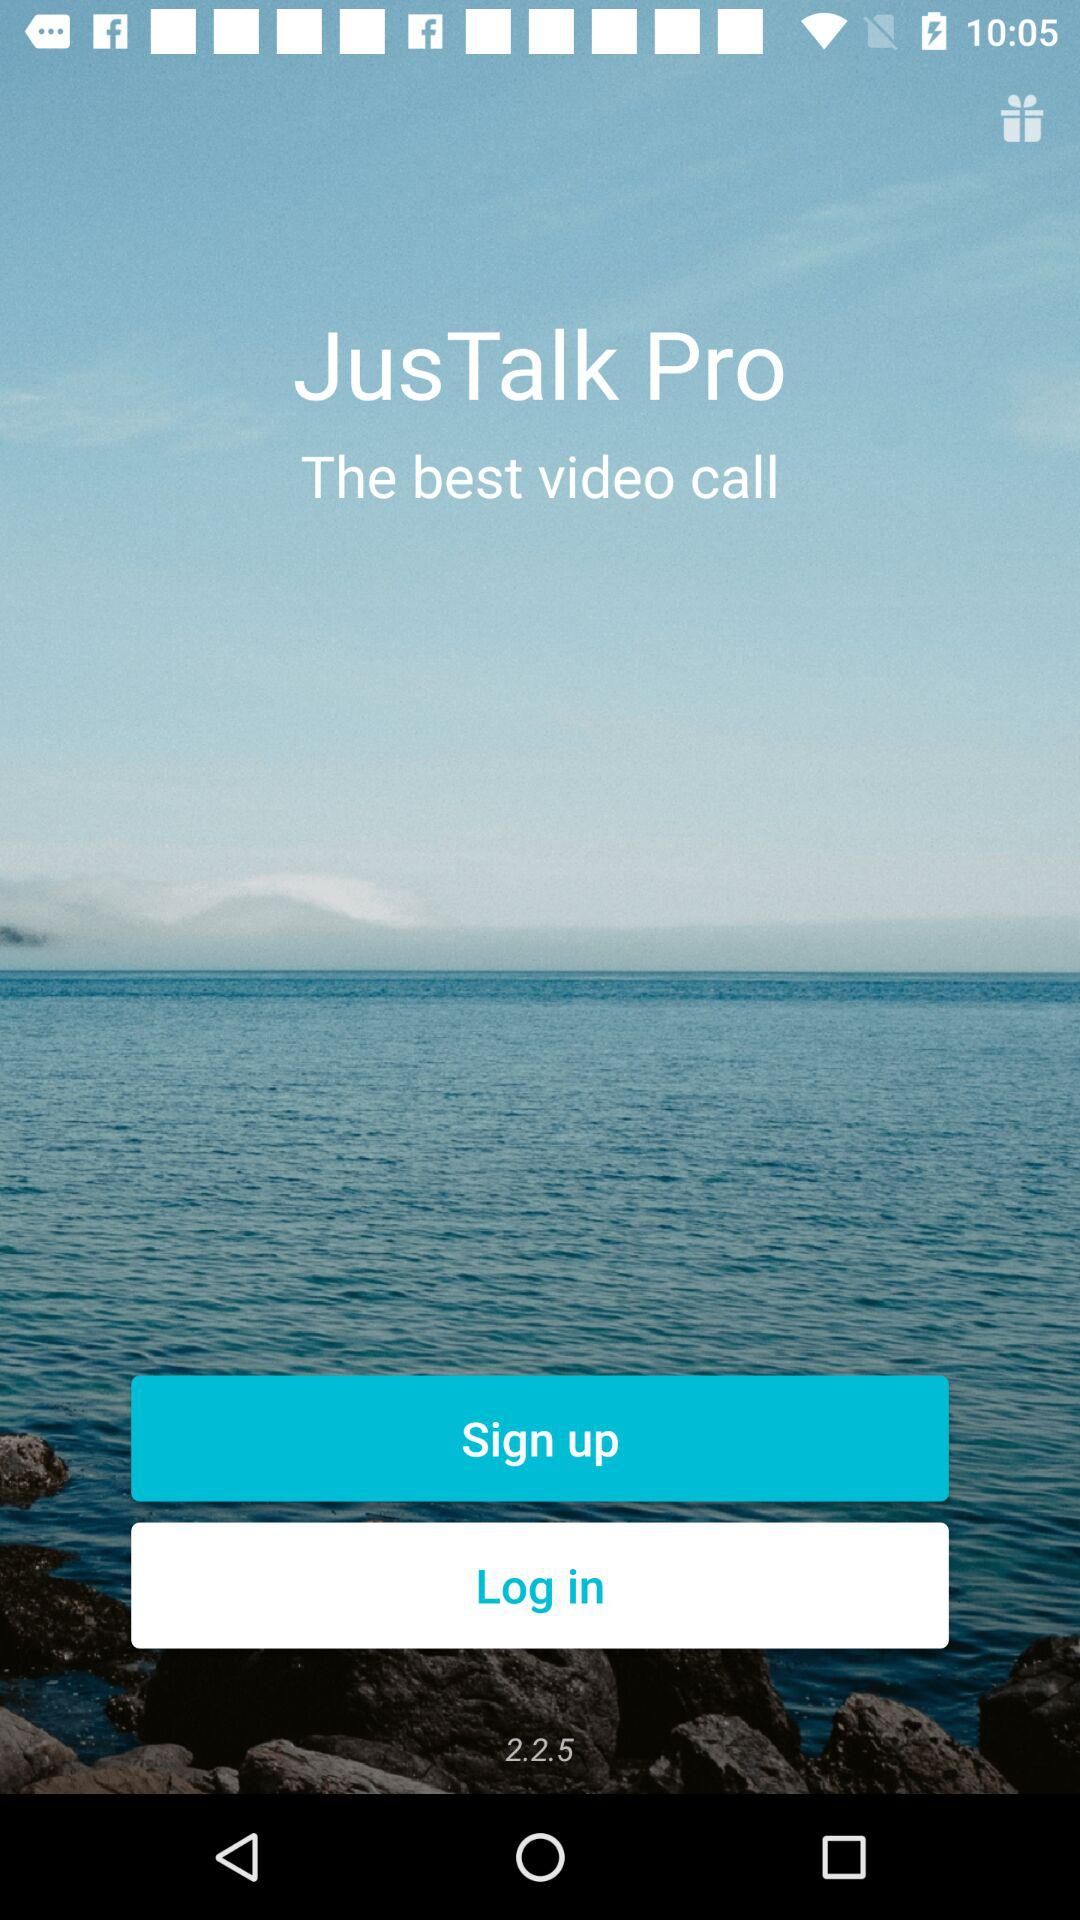What is the name of the application? The name of the application is "JusTalk Pro". 